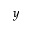<formula> <loc_0><loc_0><loc_500><loc_500>y</formula> 